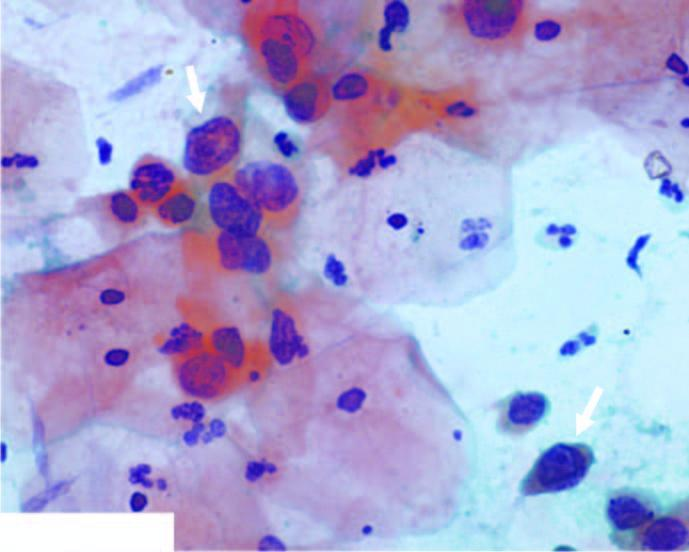what did scanty cytoplasm and markedly hyperchromatic nuclei have?
Answer the question using a single word or phrase. Irregular nuclear outlines 